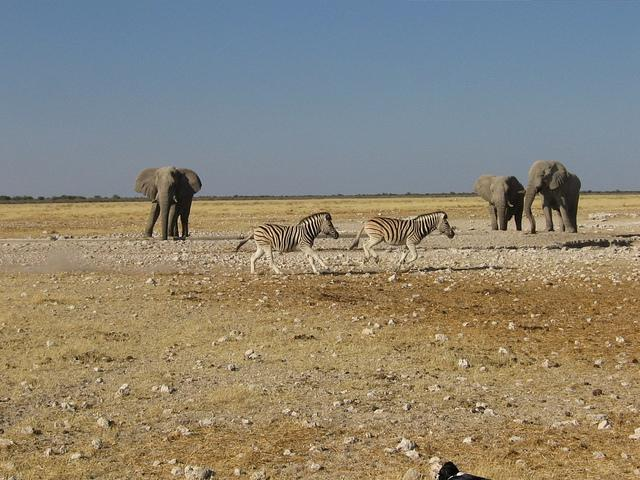How many zebras are running across the rocky field?

Choices:
A) six
B) two
C) three
D) five two 